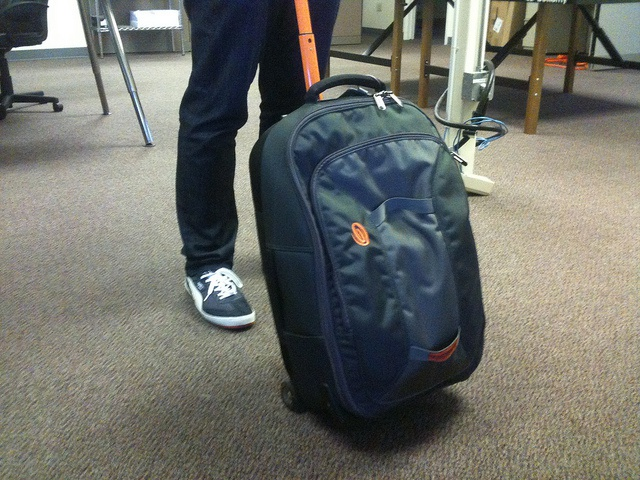Describe the objects in this image and their specific colors. I can see suitcase in black, navy, gray, and blue tones, people in black, gray, and white tones, chair in black, olive, gray, and darkgray tones, chair in black and purple tones, and chair in black, gray, darkgray, lightgray, and lightblue tones in this image. 